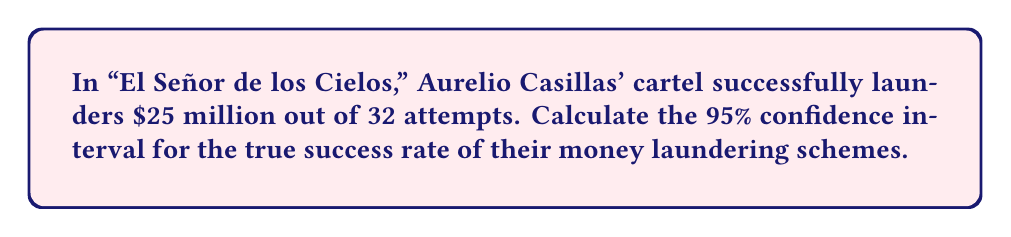Help me with this question. Let's approach this step-by-step:

1) First, we identify our parameters:
   - Number of successes (x) = 25
   - Number of trials (n) = 32
   - Confidence level = 95% (z = 1.96)

2) Calculate the sample proportion (p):
   $$ p = \frac{x}{n} = \frac{25}{32} = 0.78125 $$

3) Calculate the standard error (SE):
   $$ SE = \sqrt{\frac{p(1-p)}{n}} = \sqrt{\frac{0.78125(1-0.78125)}{32}} = 0.0731 $$

4) The formula for the confidence interval is:
   $$ CI = p \pm z \times SE $$

5) Plugging in our values:
   $$ CI = 0.78125 \pm 1.96 \times 0.0731 $$

6) Calculate the margin of error:
   $$ 1.96 \times 0.0731 = 0.1433 $$

7) Therefore, our confidence interval is:
   $$ 0.78125 - 0.1433 \text{ to } 0.78125 + 0.1433 $$
   $$ 0.63795 \text{ to } 0.92455 $$

8) Rounding to 4 decimal places:
   $$ 0.6380 \text{ to } 0.9246 $$
Answer: (0.6380, 0.9246) 